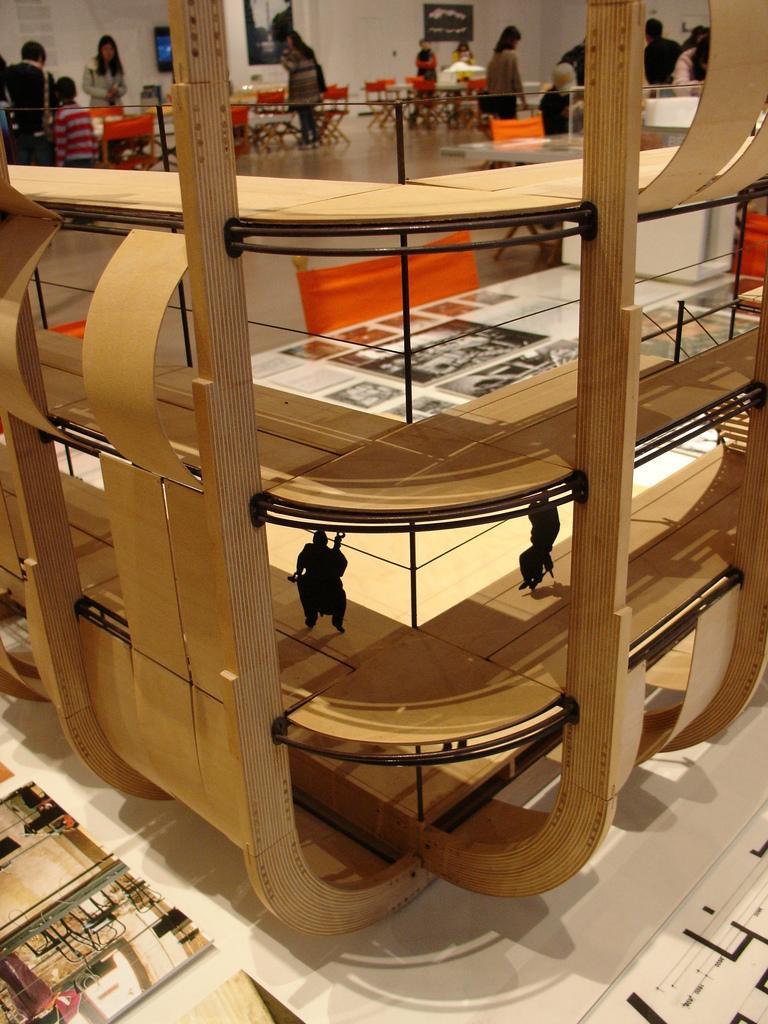In one or two sentences, can you explain what this image depicts? In this image we can see a object which is made with wood is on the table and in the background of the image there are some persons sitting on chairs around the tables, some are standing and there is a wall. 